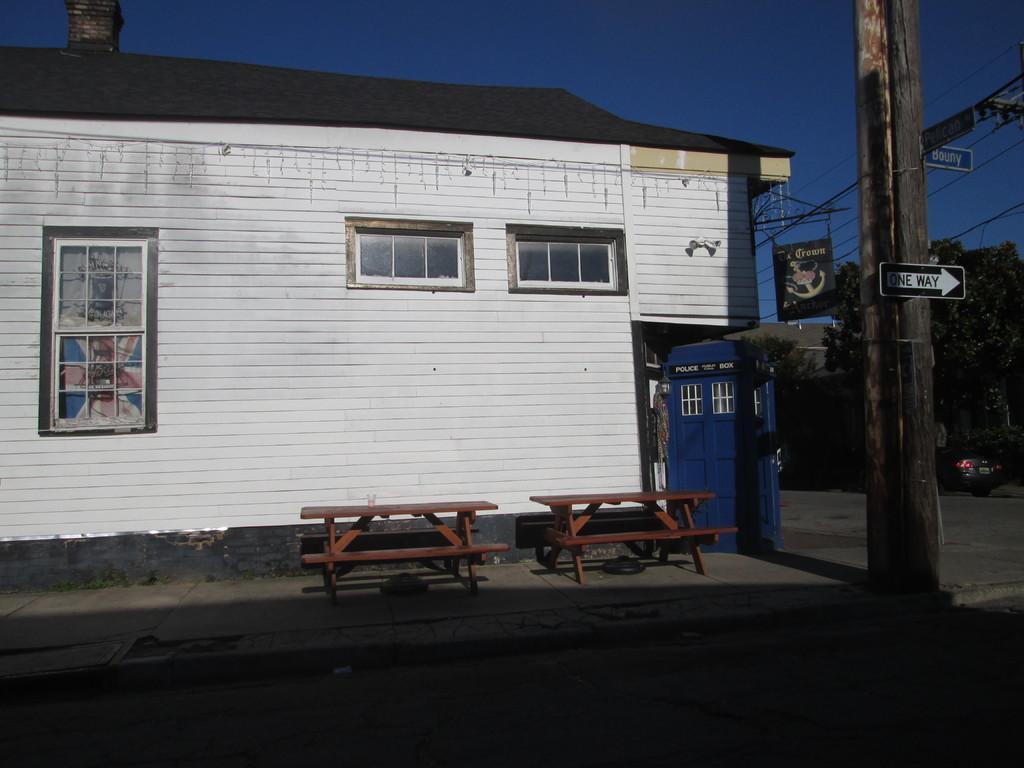Describe this image in one or two sentences. As we can see in the image there is a building, windows, benches, pole, banner, trees and at the top there is sky. The image is little dark. 